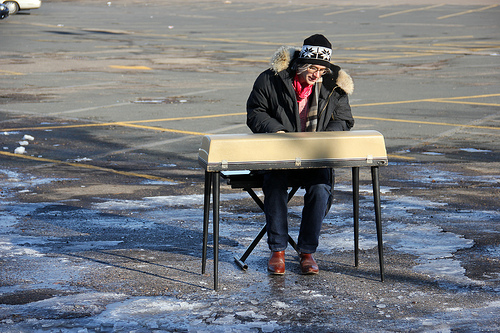<image>
Is the man in front of the table? Yes. The man is positioned in front of the table, appearing closer to the camera viewpoint. Is the car above the person? No. The car is not positioned above the person. The vertical arrangement shows a different relationship. 